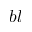<formula> <loc_0><loc_0><loc_500><loc_500>b l</formula> 